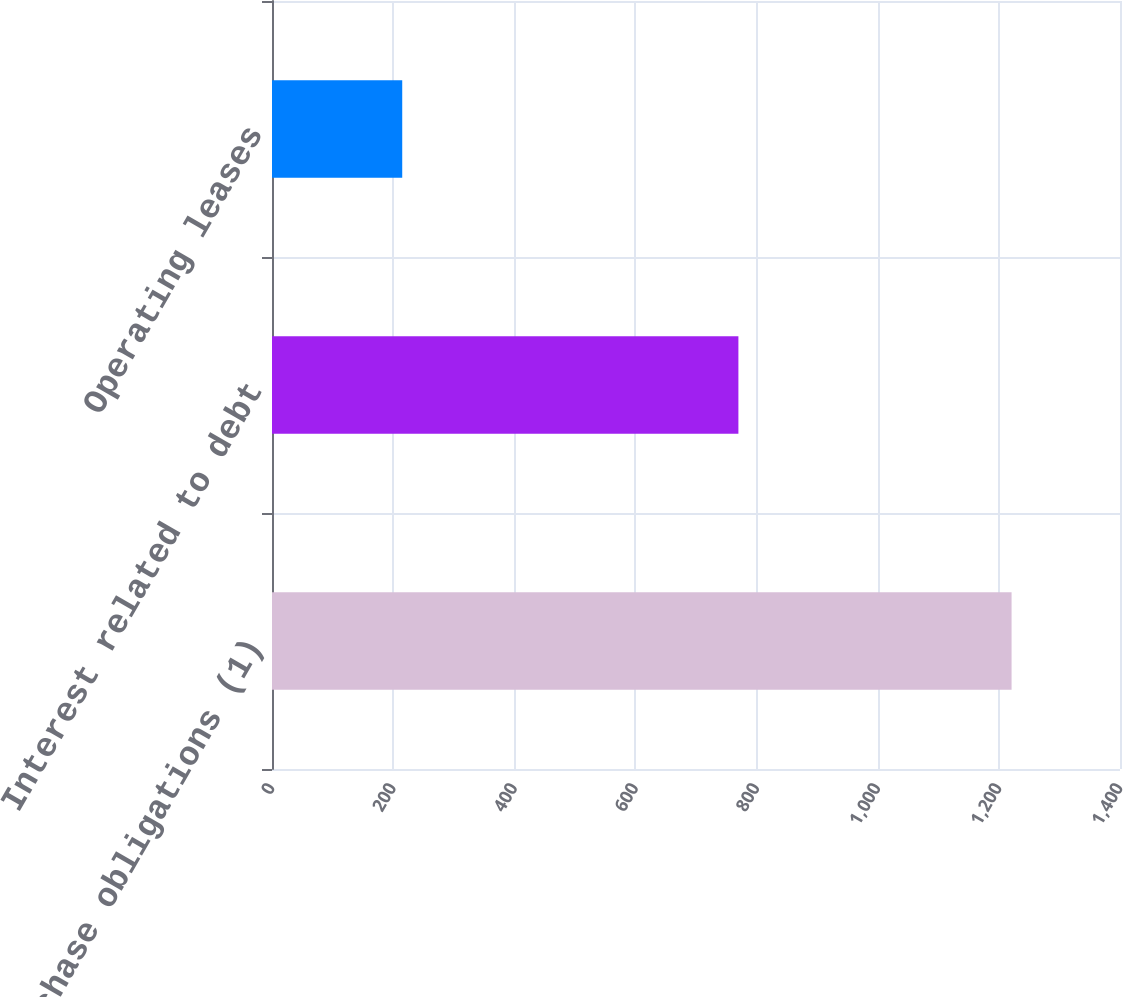<chart> <loc_0><loc_0><loc_500><loc_500><bar_chart><fcel>Purchase obligations (1)<fcel>Interest related to debt<fcel>Operating leases<nl><fcel>1221<fcel>770<fcel>215<nl></chart> 